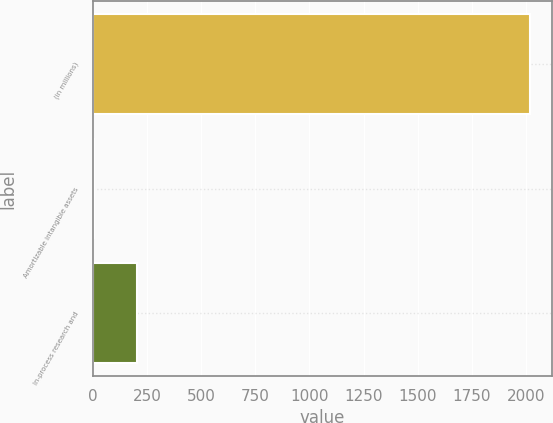<chart> <loc_0><loc_0><loc_500><loc_500><bar_chart><fcel>(in millions)<fcel>Amortizable intangible assets<fcel>In-process research and<nl><fcel>2016<fcel>4<fcel>205.2<nl></chart> 